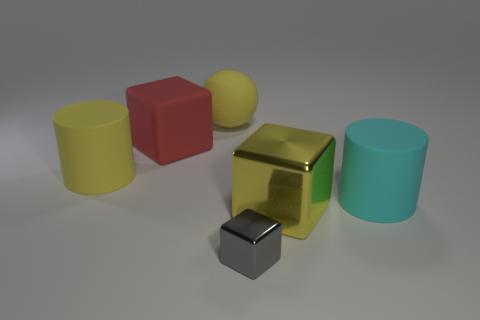There is a rubber cylinder in front of the rubber cylinder that is left of the big red block; what color is it?
Your response must be concise. Cyan. There is a rubber cylinder to the left of the tiny thing; is it the same color as the matte ball?
Your answer should be compact. Yes. There is a cube that is left of the small gray block; what material is it?
Provide a succinct answer. Rubber. How big is the red matte cube?
Keep it short and to the point. Large. Does the large cylinder to the right of the large yellow metal block have the same material as the red thing?
Ensure brevity in your answer.  Yes. What number of tiny blocks are there?
Provide a short and direct response. 1. How many things are either yellow matte cylinders or large red rubber blocks?
Your answer should be compact. 2. There is a cylinder that is right of the big block that is on the right side of the tiny gray block; what number of tiny gray metal blocks are on the right side of it?
Make the answer very short. 0. Are there any other things of the same color as the tiny block?
Make the answer very short. No. Does the shiny thing behind the small gray metal thing have the same color as the cylinder to the left of the big metallic thing?
Provide a succinct answer. Yes. 